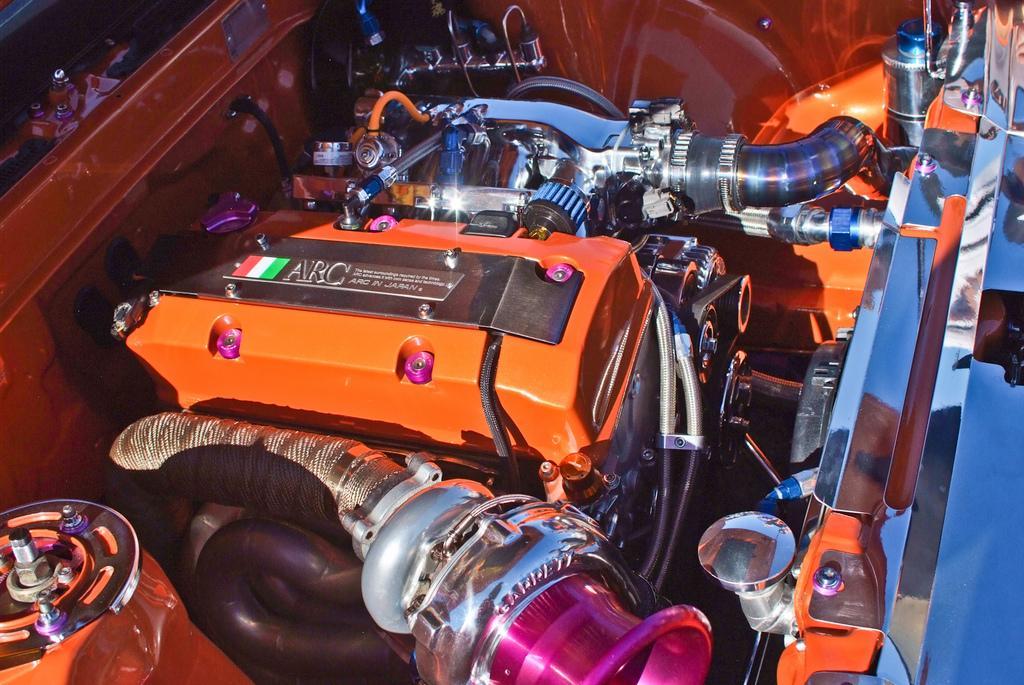How would you summarize this image in a sentence or two? This image is a inside picture of a cars bonnet. 